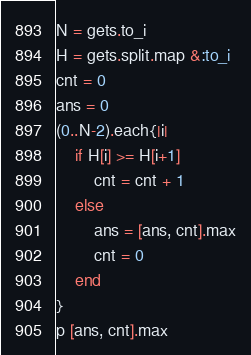<code> <loc_0><loc_0><loc_500><loc_500><_Ruby_>N = gets.to_i
H = gets.split.map &:to_i
cnt = 0
ans = 0
(0..N-2).each{|i|
	if H[i] >= H[i+1]
		cnt = cnt + 1
	else
		ans = [ans, cnt].max
		cnt = 0
	end
}
p [ans, cnt].max</code> 